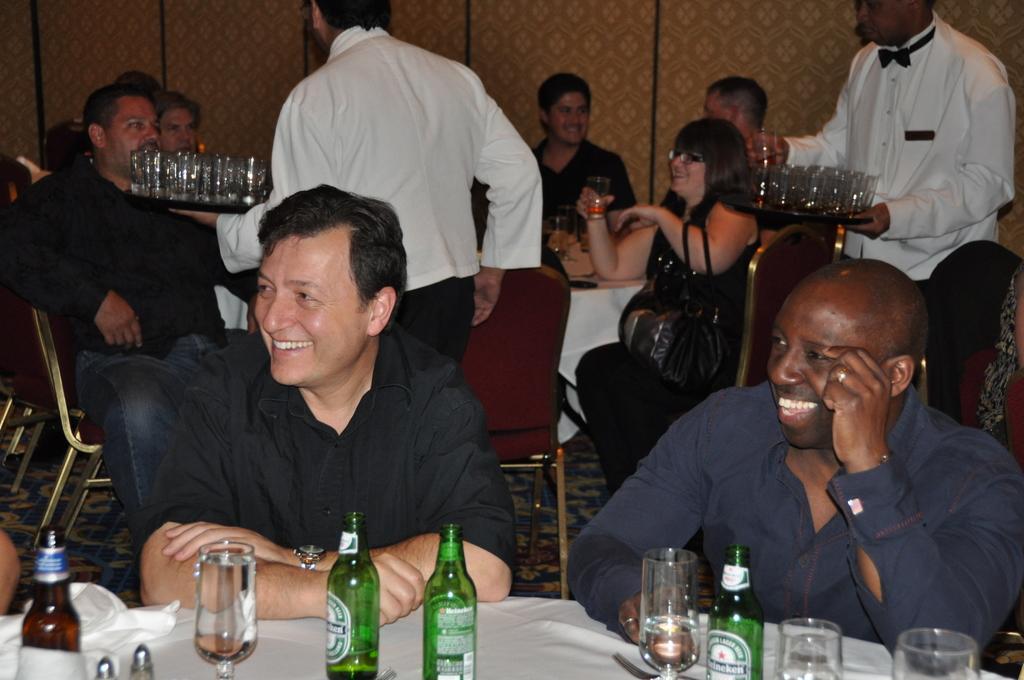In one or two sentences, can you explain what this image depicts? In this image there are group of people sitting on the chair. There are two person holding a plate full of glass. In front the man is smiling. In front of the man there is a table. On the table there is a bottle and a glass. 